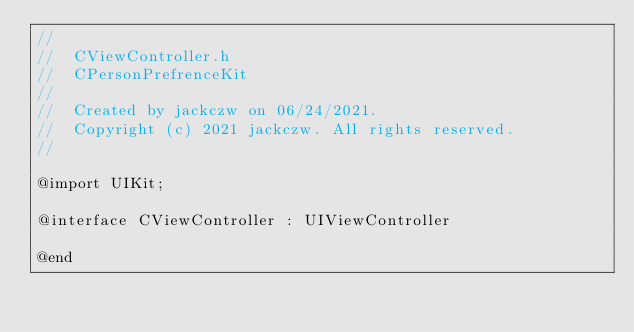Convert code to text. <code><loc_0><loc_0><loc_500><loc_500><_C_>//
//  CViewController.h
//  CPersonPrefrenceKit
//
//  Created by jackczw on 06/24/2021.
//  Copyright (c) 2021 jackczw. All rights reserved.
//

@import UIKit;

@interface CViewController : UIViewController

@end
</code> 